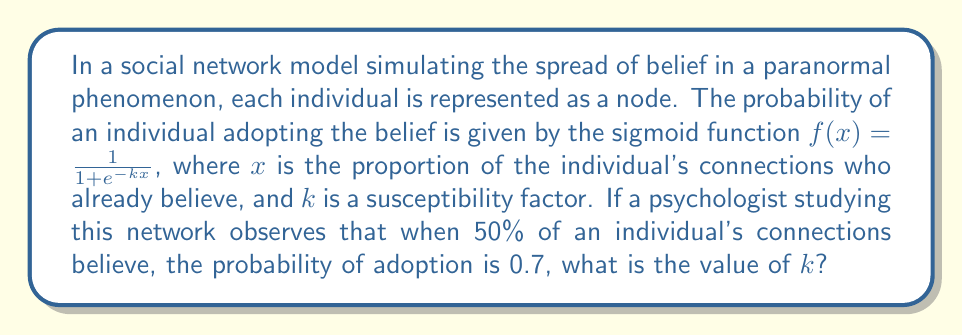Help me with this question. To solve this problem, we need to use the given information and the sigmoid function to determine the value of $k$. Let's approach this step-by-step:

1) We are given that $f(x) = \frac{1}{1 + e^{-kx}}$ is the probability of adopting the belief.

2) We know that when 50% of connections believe (x = 0.5), the probability of adoption is 0.7.

3) Let's substitute these values into the equation:

   $0.7 = \frac{1}{1 + e^{-k(0.5)}}$

4) Now, let's solve this equation for $k$:

   $0.7(1 + e^{-0.5k}) = 1$
   $1 + e^{-0.5k} = \frac{1}{0.7}$
   $e^{-0.5k} = \frac{1}{0.7} - 1 = \frac{10}{7} - 1 = \frac{3}{7}$

5) Taking the natural log of both sides:

   $-0.5k = \ln(\frac{3}{7})$

6) Solving for $k$:

   $k = -2\ln(\frac{3}{7}) \approx 1.6946$

Therefore, the susceptibility factor $k$ is approximately 1.6946.
Answer: $k \approx 1.6946$ 